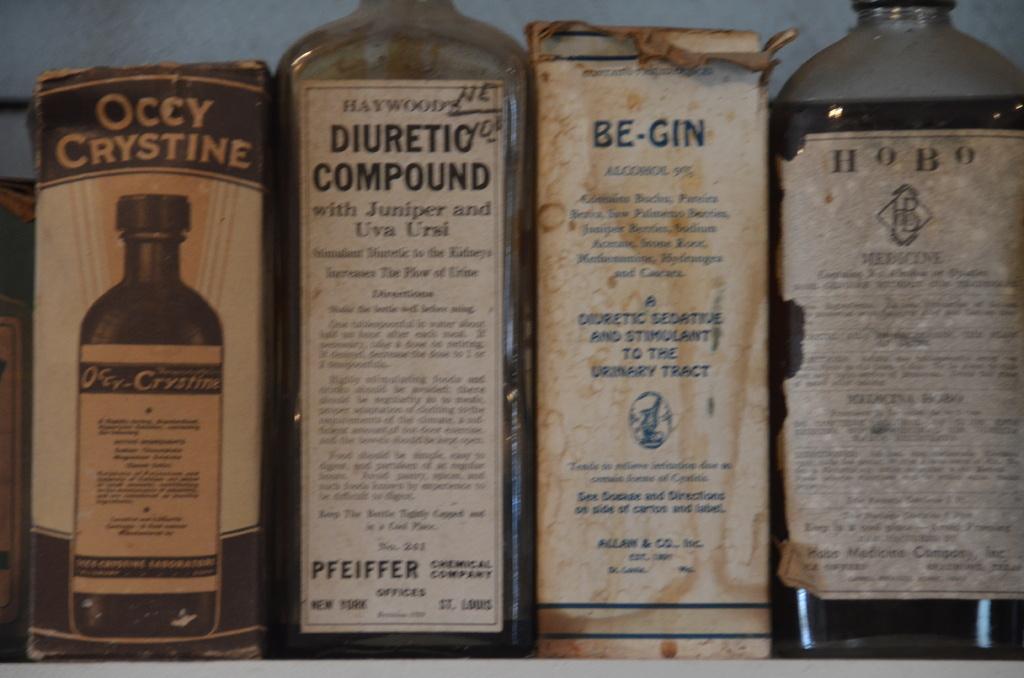Is one of these good for the urinary tract?
Ensure brevity in your answer.  Yes. What is the name at the top of the first box?
Offer a very short reply. Occy crystine. 